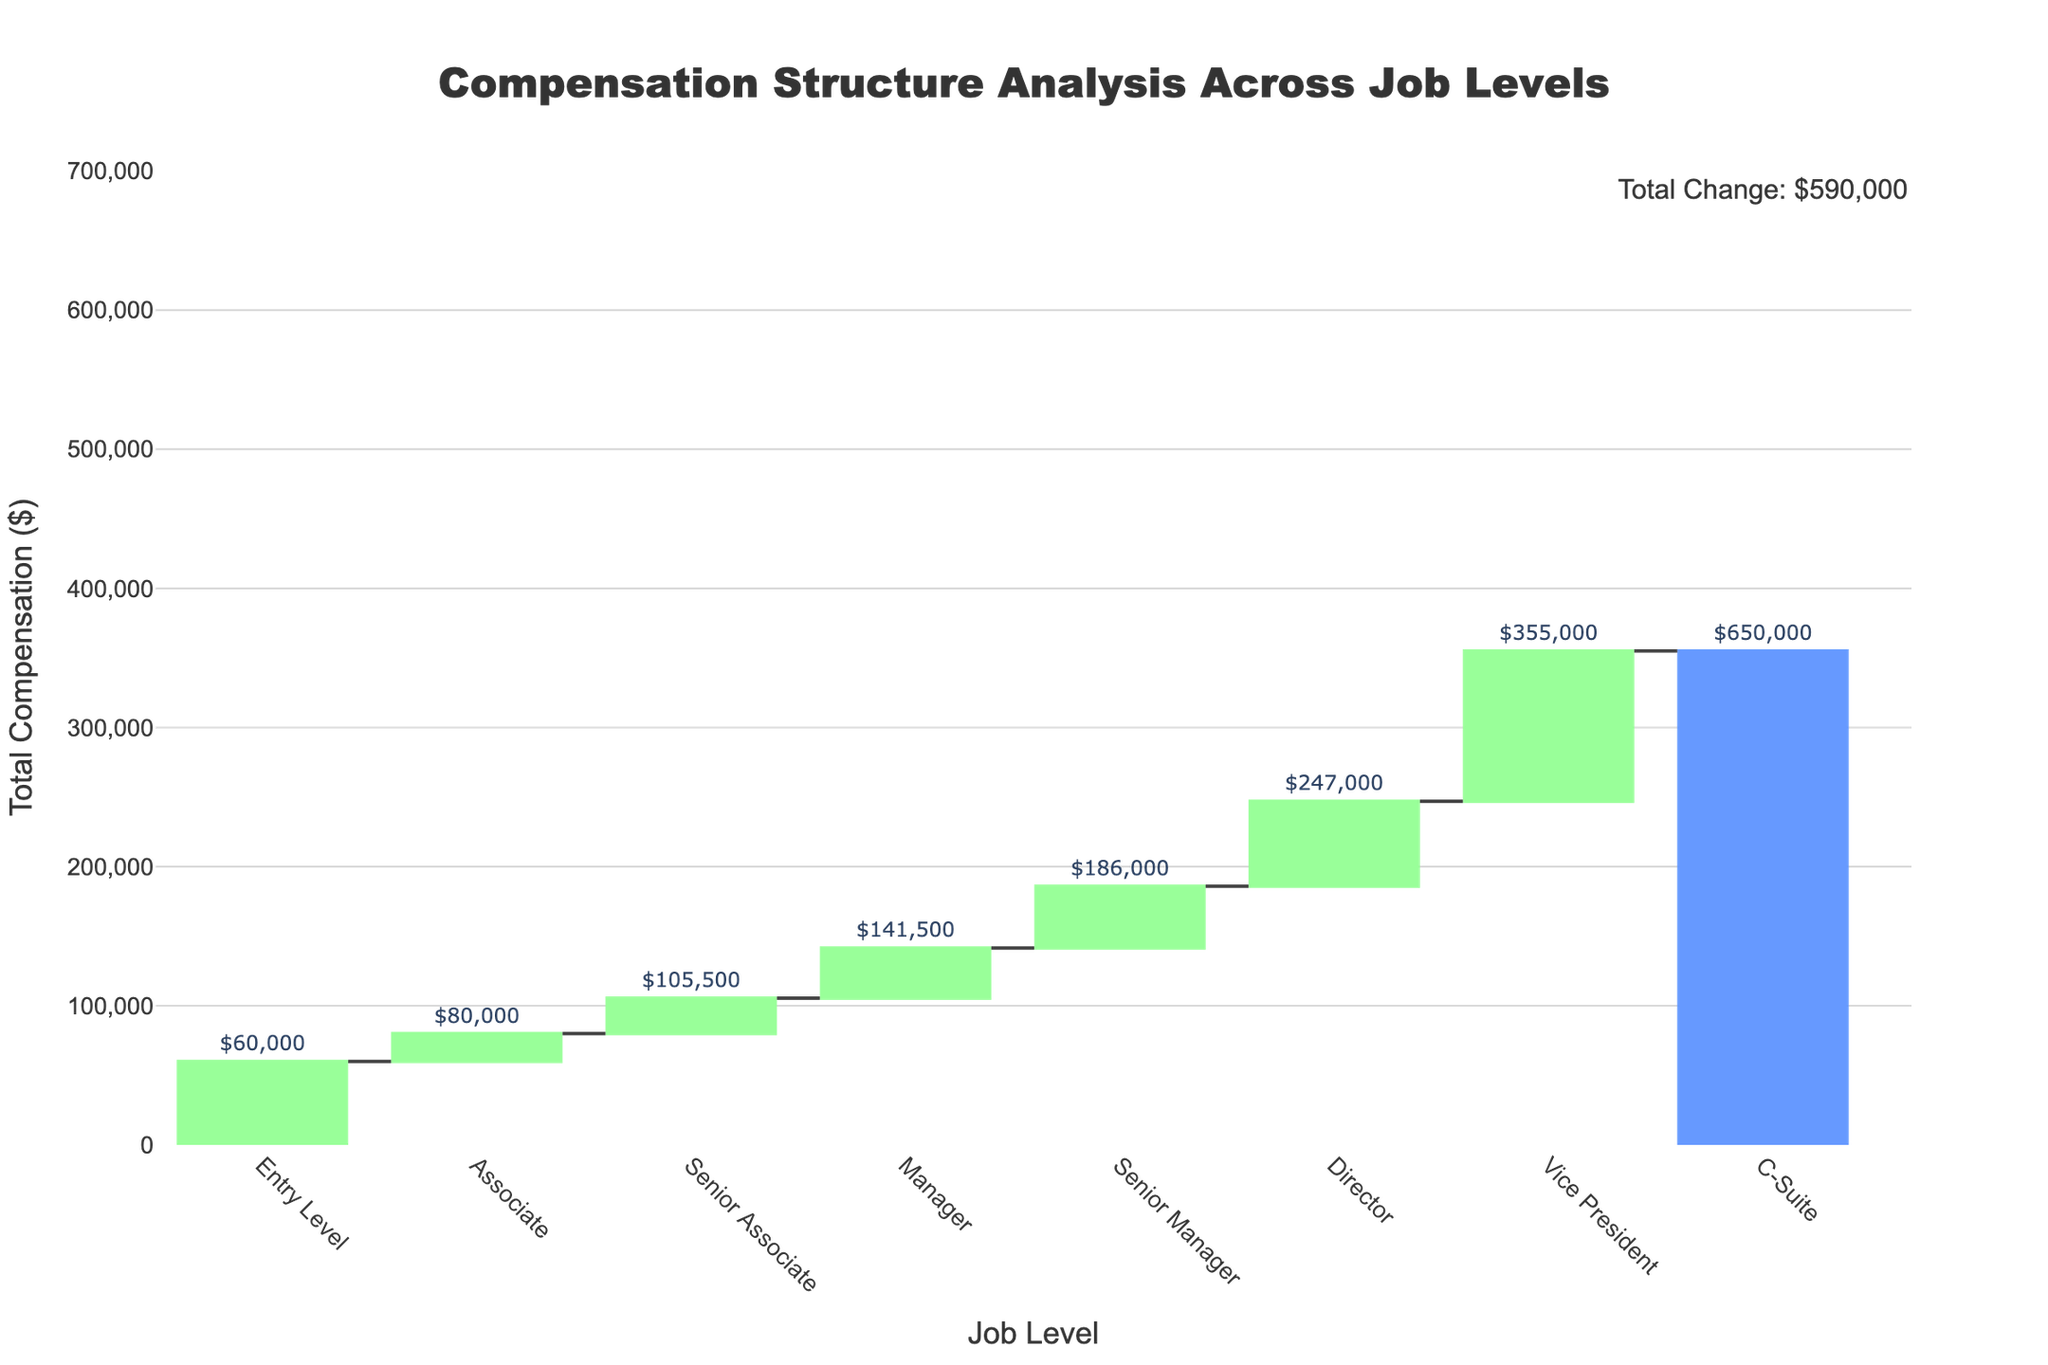What is the title of the chart? The title of the chart is located at the top and clearly states the purpose of the chart. By reading the title, we can understand that the chart analyzes the compensation structure across different job levels.
Answer: "Compensation Structure Analysis Across Job Levels" What is the total compensation for a Vice President? The total compensation for each job level is displayed above the corresponding bar. For Vice President, the text above the seventh bar shows the total compensation.
Answer: $355,000 How much is the total change in compensation from Entry Level to C-Suite? Look above the C-Suite bar where there is an annotation indicating the total change. This amount represents the difference between the total compensation of the C-Suite and the Entry Level.
Answer: $590,000 Which job level has the highest increase in total compensation from the previous level? To find the highest increase, we need to compare the height differences of the bars representing each job level. The largest increase is observed between the Manager and Senior Manager bars.
Answer: Senior Manager What components make up the total compensation for an Entry Level position? By observing the breakdown and reading the initial data point for Entry Level, we see it includes base salary, bonus, and benefits. The total compensation for Entry Level is shown as $60,000, which includes a base salary of $50,000, a bonus of $2,500, and benefits of $7,500.
Answer: Base salary: $50,000, Bonus: $2,500, Benefits: $7,500 What is the difference between the total compensation of a Director and a Senior Manager? To determine the difference, subtract the total compensation of the Senior Manager from that of the Director. The values above each bar show $247,000 for Director and $186,000 for Senior Manager.
Answer: $61,000 What job levels have a total compensation above $200,000? By examining the bars representing each job level and looking for those with a total compensation above $200,000, we find that Director, Vice President, and C-Suite meet this criterion.
Answer: Director, Vice President, C-Suite How much does the bonus component increase from Manager to Senior Manager? Compare the bonus amounts between Manager and Senior Manager from the initial data provided. Manager has a bonus of $16,500 and Senior Manager has a bonus of $28,000. The increase is calculated by subtracting the Manager's bonus from the Senior Manager's bonus.
Answer: $11,500 What is the average total compensation for the first three job levels? To calculate the average, sum up the total compensations for Entry Level, Associate, and Senior Associate, then divide by three. The totals are $60,000, $80,000, and $105,500, respectively. The sum is $245,500, and the average is $245,500 / 3.
Answer: $81,833 Between which job levels is the smallest increase in total compensation observed? By visually comparing the differences between consecutive bars, we find that the smallest increase occurs between Entry Level and Associate.
Answer: Entry Level and Associate 